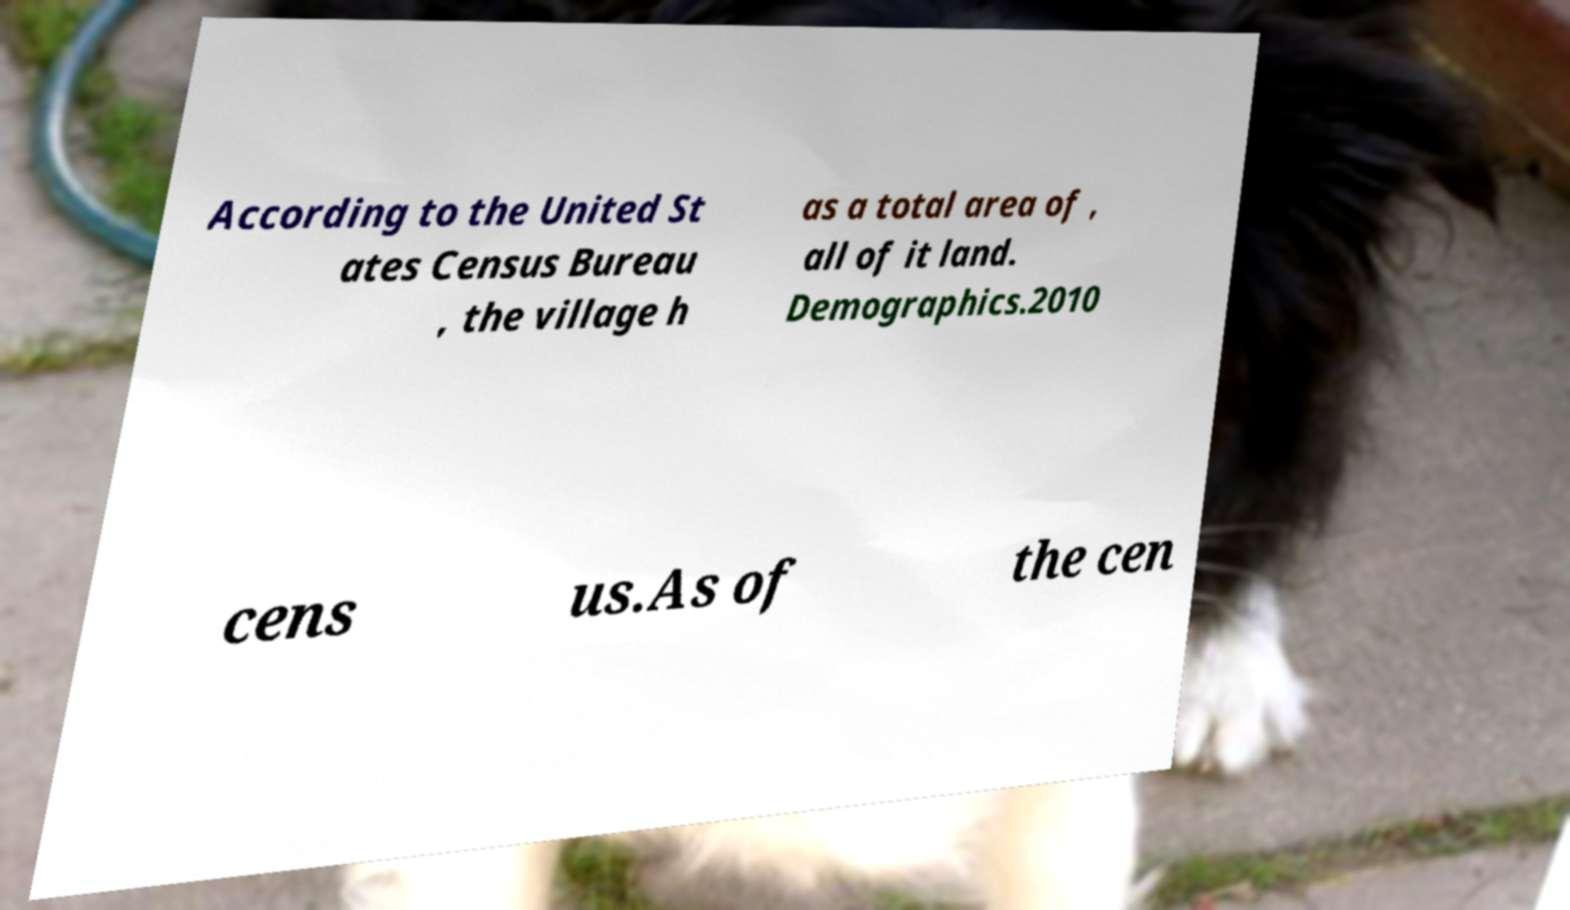Please identify and transcribe the text found in this image. According to the United St ates Census Bureau , the village h as a total area of , all of it land. Demographics.2010 cens us.As of the cen 